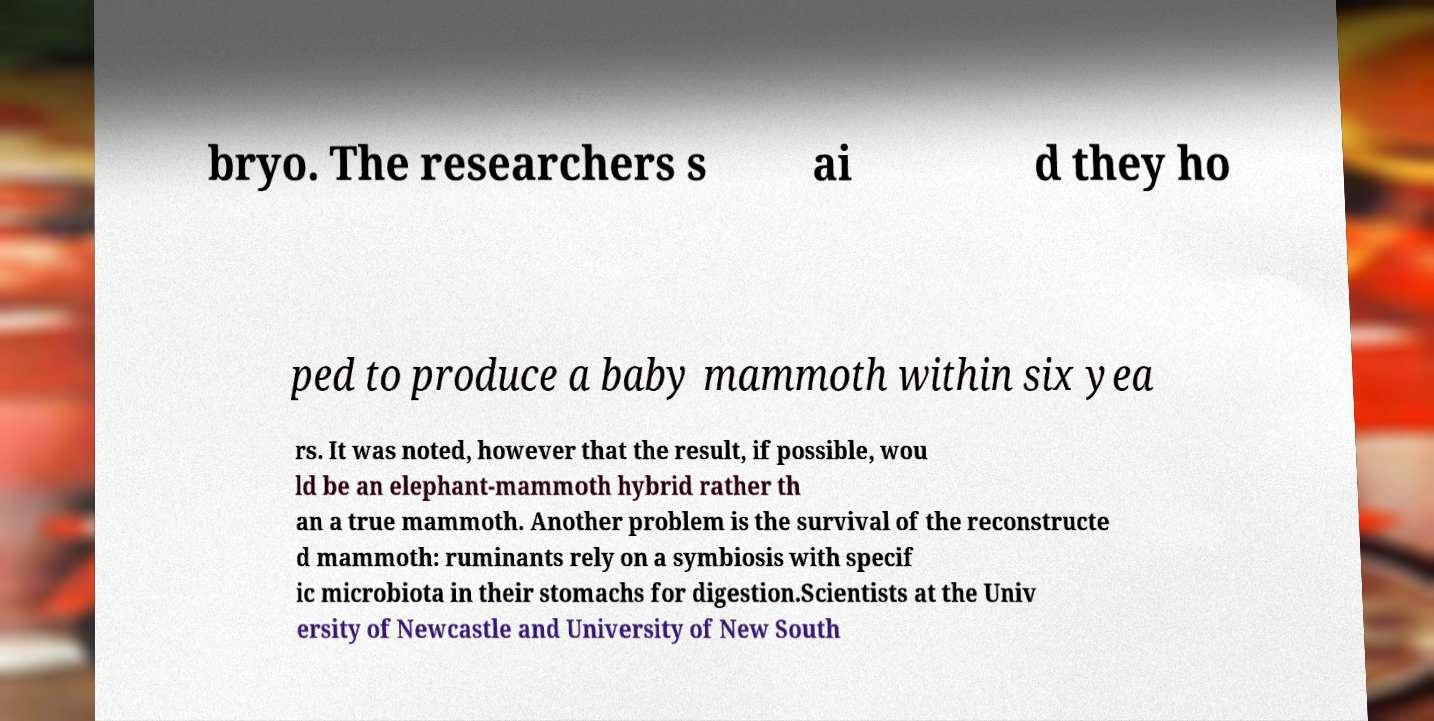For documentation purposes, I need the text within this image transcribed. Could you provide that? bryo. The researchers s ai d they ho ped to produce a baby mammoth within six yea rs. It was noted, however that the result, if possible, wou ld be an elephant-mammoth hybrid rather th an a true mammoth. Another problem is the survival of the reconstructe d mammoth: ruminants rely on a symbiosis with specif ic microbiota in their stomachs for digestion.Scientists at the Univ ersity of Newcastle and University of New South 